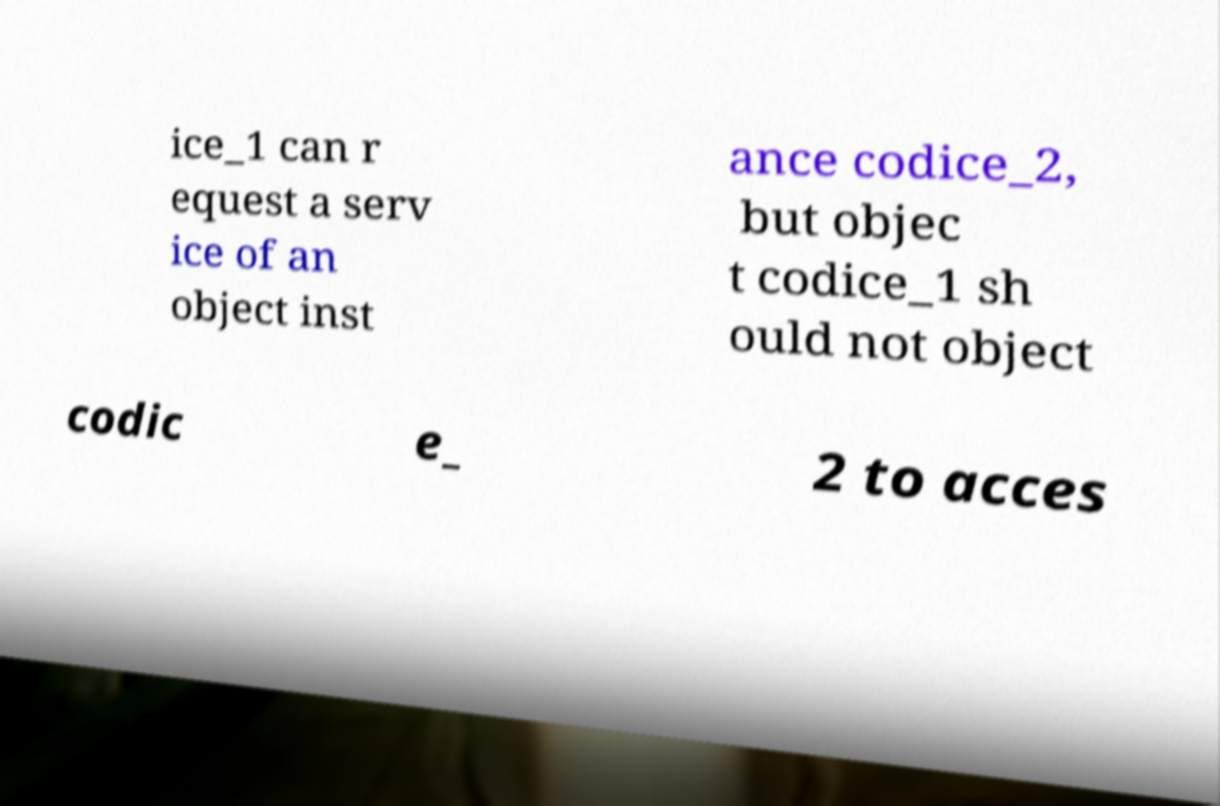Can you read and provide the text displayed in the image?This photo seems to have some interesting text. Can you extract and type it out for me? ice_1 can r equest a serv ice of an object inst ance codice_2, but objec t codice_1 sh ould not object codic e_ 2 to acces 